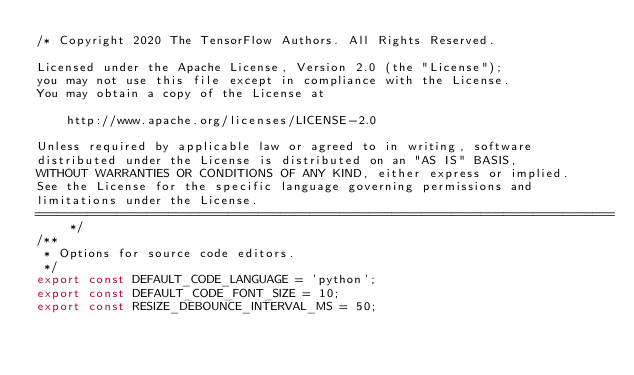Convert code to text. <code><loc_0><loc_0><loc_500><loc_500><_TypeScript_>/* Copyright 2020 The TensorFlow Authors. All Rights Reserved.

Licensed under the Apache License, Version 2.0 (the "License");
you may not use this file except in compliance with the License.
You may obtain a copy of the License at

    http://www.apache.org/licenses/LICENSE-2.0

Unless required by applicable law or agreed to in writing, software
distributed under the License is distributed on an "AS IS" BASIS,
WITHOUT WARRANTIES OR CONDITIONS OF ANY KIND, either express or implied.
See the License for the specific language governing permissions and
limitations under the License.
==============================================================================*/
/**
 * Options for source code editors.
 */
export const DEFAULT_CODE_LANGUAGE = 'python';
export const DEFAULT_CODE_FONT_SIZE = 10;
export const RESIZE_DEBOUNCE_INTERVAL_MS = 50;
</code> 